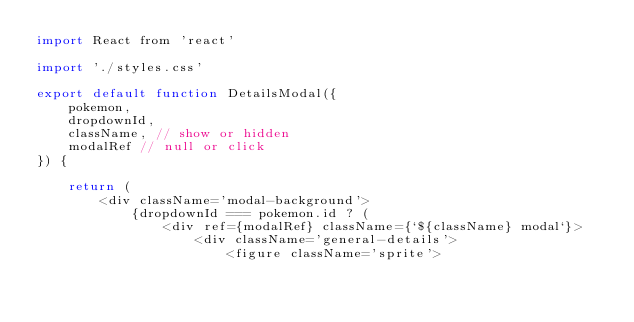<code> <loc_0><loc_0><loc_500><loc_500><_JavaScript_>import React from 'react'

import './styles.css'

export default function DetailsModal({
    pokemon,
    dropdownId,
    className, // show or hidden
    modalRef // null or click
}) {

    return (
        <div className='modal-background'>
            {dropdownId === pokemon.id ? (
                <div ref={modalRef} className={`${className} modal`}>
                    <div className='general-details'>
                        <figure className='sprite'></code> 